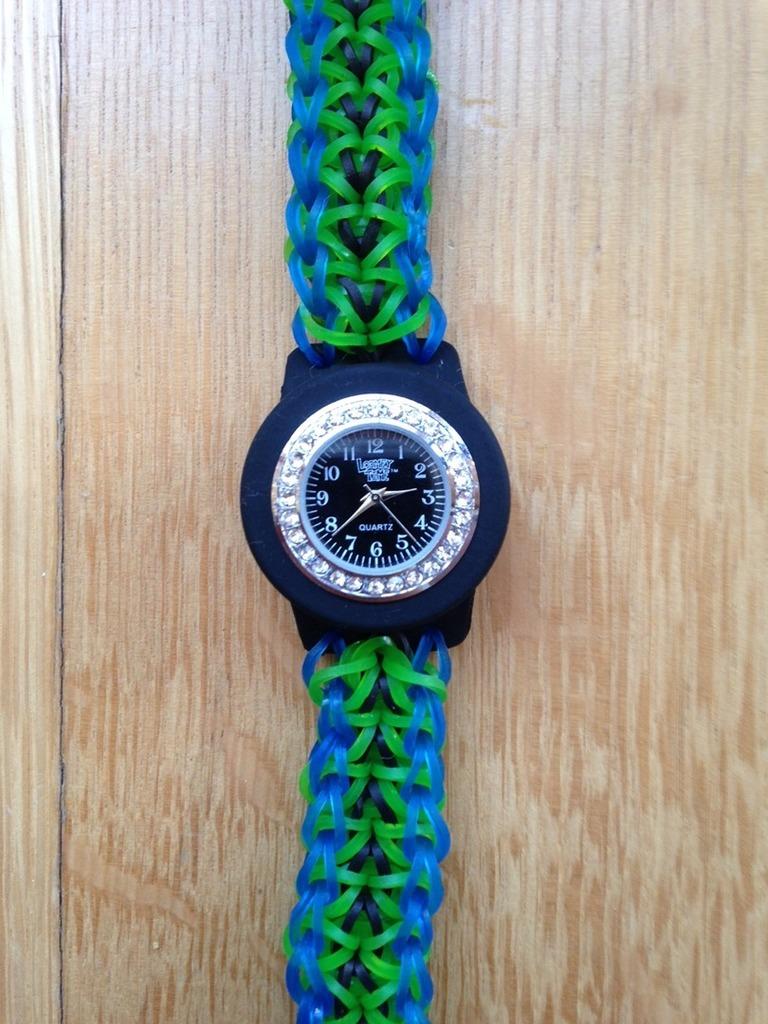This a watch?
Your response must be concise. Answering does not require reading text in the image. 